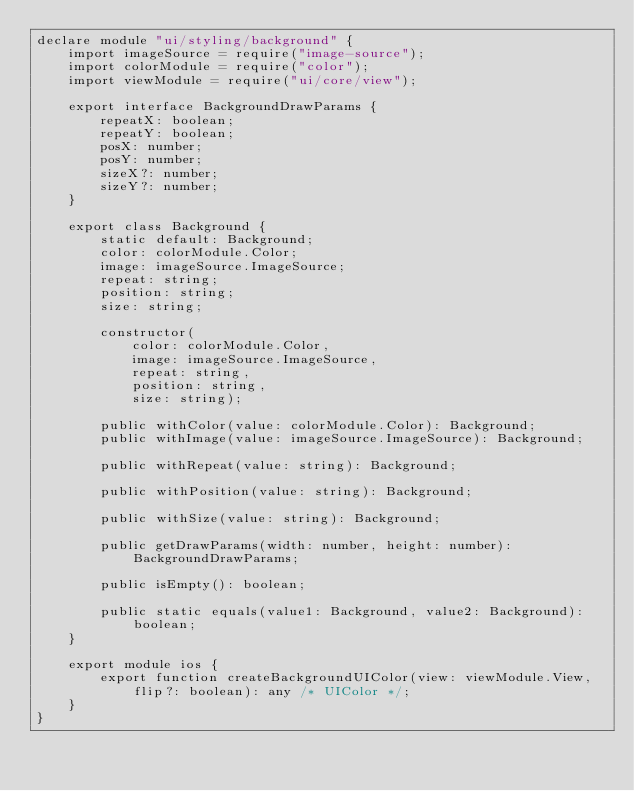Convert code to text. <code><loc_0><loc_0><loc_500><loc_500><_TypeScript_>declare module "ui/styling/background" {
    import imageSource = require("image-source");
    import colorModule = require("color");
    import viewModule = require("ui/core/view");

    export interface BackgroundDrawParams {
        repeatX: boolean;
        repeatY: boolean;
        posX: number;
        posY: number;
        sizeX?: number;
        sizeY?: number;
    }

    export class Background {
        static default: Background;
        color: colorModule.Color;
        image: imageSource.ImageSource;
        repeat: string;
        position: string;
        size: string;

        constructor(
            color: colorModule.Color,
            image: imageSource.ImageSource,
            repeat: string,
            position: string,
            size: string);

        public withColor(value: colorModule.Color): Background;
        public withImage(value: imageSource.ImageSource): Background;

        public withRepeat(value: string): Background;

        public withPosition(value: string): Background;

        public withSize(value: string): Background;

        public getDrawParams(width: number, height: number): BackgroundDrawParams;

        public isEmpty(): boolean;

        public static equals(value1: Background, value2: Background): boolean;
    }

    export module ios {
        export function createBackgroundUIColor(view: viewModule.View, flip?: boolean): any /* UIColor */;
    }
}
</code> 